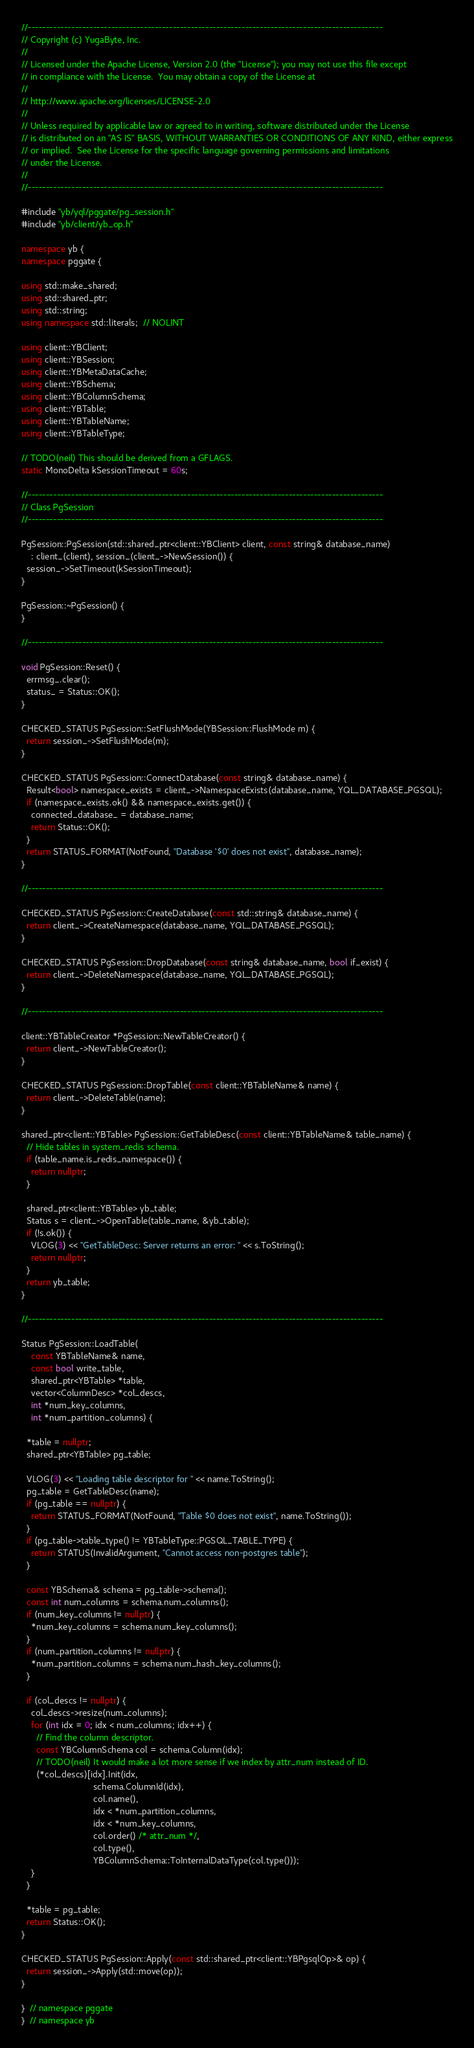<code> <loc_0><loc_0><loc_500><loc_500><_C++_>//--------------------------------------------------------------------------------------------------
// Copyright (c) YugaByte, Inc.
//
// Licensed under the Apache License, Version 2.0 (the "License"); you may not use this file except
// in compliance with the License.  You may obtain a copy of the License at
//
// http://www.apache.org/licenses/LICENSE-2.0
//
// Unless required by applicable law or agreed to in writing, software distributed under the License
// is distributed on an "AS IS" BASIS, WITHOUT WARRANTIES OR CONDITIONS OF ANY KIND, either express
// or implied.  See the License for the specific language governing permissions and limitations
// under the License.
//
//--------------------------------------------------------------------------------------------------

#include "yb/yql/pggate/pg_session.h"
#include "yb/client/yb_op.h"

namespace yb {
namespace pggate {

using std::make_shared;
using std::shared_ptr;
using std::string;
using namespace std::literals;  // NOLINT

using client::YBClient;
using client::YBSession;
using client::YBMetaDataCache;
using client::YBSchema;
using client::YBColumnSchema;
using client::YBTable;
using client::YBTableName;
using client::YBTableType;

// TODO(neil) This should be derived from a GFLAGS.
static MonoDelta kSessionTimeout = 60s;

//--------------------------------------------------------------------------------------------------
// Class PgSession
//--------------------------------------------------------------------------------------------------

PgSession::PgSession(std::shared_ptr<client::YBClient> client, const string& database_name)
    : client_(client), session_(client_->NewSession()) {
  session_->SetTimeout(kSessionTimeout);
}

PgSession::~PgSession() {
}

//--------------------------------------------------------------------------------------------------

void PgSession::Reset() {
  errmsg_.clear();
  status_ = Status::OK();
}

CHECKED_STATUS PgSession::SetFlushMode(YBSession::FlushMode m) {
  return session_->SetFlushMode(m);
}

CHECKED_STATUS PgSession::ConnectDatabase(const string& database_name) {
  Result<bool> namespace_exists = client_->NamespaceExists(database_name, YQL_DATABASE_PGSQL);
  if (namespace_exists.ok() && namespace_exists.get()) {
    connected_database_ = database_name;
    return Status::OK();
  }
  return STATUS_FORMAT(NotFound, "Database '$0' does not exist", database_name);
}

//--------------------------------------------------------------------------------------------------

CHECKED_STATUS PgSession::CreateDatabase(const std::string& database_name) {
  return client_->CreateNamespace(database_name, YQL_DATABASE_PGSQL);
}

CHECKED_STATUS PgSession::DropDatabase(const string& database_name, bool if_exist) {
  return client_->DeleteNamespace(database_name, YQL_DATABASE_PGSQL);
}

//--------------------------------------------------------------------------------------------------

client::YBTableCreator *PgSession::NewTableCreator() {
  return client_->NewTableCreator();
}

CHECKED_STATUS PgSession::DropTable(const client::YBTableName& name) {
  return client_->DeleteTable(name);
}

shared_ptr<client::YBTable> PgSession::GetTableDesc(const client::YBTableName& table_name) {
  // Hide tables in system_redis schema.
  if (table_name.is_redis_namespace()) {
    return nullptr;
  }

  shared_ptr<client::YBTable> yb_table;
  Status s = client_->OpenTable(table_name, &yb_table);
  if (!s.ok()) {
    VLOG(3) << "GetTableDesc: Server returns an error: " << s.ToString();
    return nullptr;
  }
  return yb_table;
}

//--------------------------------------------------------------------------------------------------

Status PgSession::LoadTable(
    const YBTableName& name,
    const bool write_table,
    shared_ptr<YBTable> *table,
    vector<ColumnDesc> *col_descs,
    int *num_key_columns,
    int *num_partition_columns) {

  *table = nullptr;
  shared_ptr<YBTable> pg_table;

  VLOG(3) << "Loading table descriptor for " << name.ToString();
  pg_table = GetTableDesc(name);
  if (pg_table == nullptr) {
    return STATUS_FORMAT(NotFound, "Table $0 does not exist", name.ToString());
  }
  if (pg_table->table_type() != YBTableType::PGSQL_TABLE_TYPE) {
    return STATUS(InvalidArgument, "Cannot access non-postgres table");
  }

  const YBSchema& schema = pg_table->schema();
  const int num_columns = schema.num_columns();
  if (num_key_columns != nullptr) {
    *num_key_columns = schema.num_key_columns();
  }
  if (num_partition_columns != nullptr) {
    *num_partition_columns = schema.num_hash_key_columns();
  }

  if (col_descs != nullptr) {
    col_descs->resize(num_columns);
    for (int idx = 0; idx < num_columns; idx++) {
      // Find the column descriptor.
      const YBColumnSchema col = schema.Column(idx);
      // TODO(neil) It would make a lot more sense if we index by attr_num instead of ID.
      (*col_descs)[idx].Init(idx,
                             schema.ColumnId(idx),
                             col.name(),
                             idx < *num_partition_columns,
                             idx < *num_key_columns,
                             col.order() /* attr_num */,
                             col.type(),
                             YBColumnSchema::ToInternalDataType(col.type()));
    }
  }

  *table = pg_table;
  return Status::OK();
}

CHECKED_STATUS PgSession::Apply(const std::shared_ptr<client::YBPgsqlOp>& op) {
  return session_->Apply(std::move(op));
}

}  // namespace pggate
}  // namespace yb
</code> 